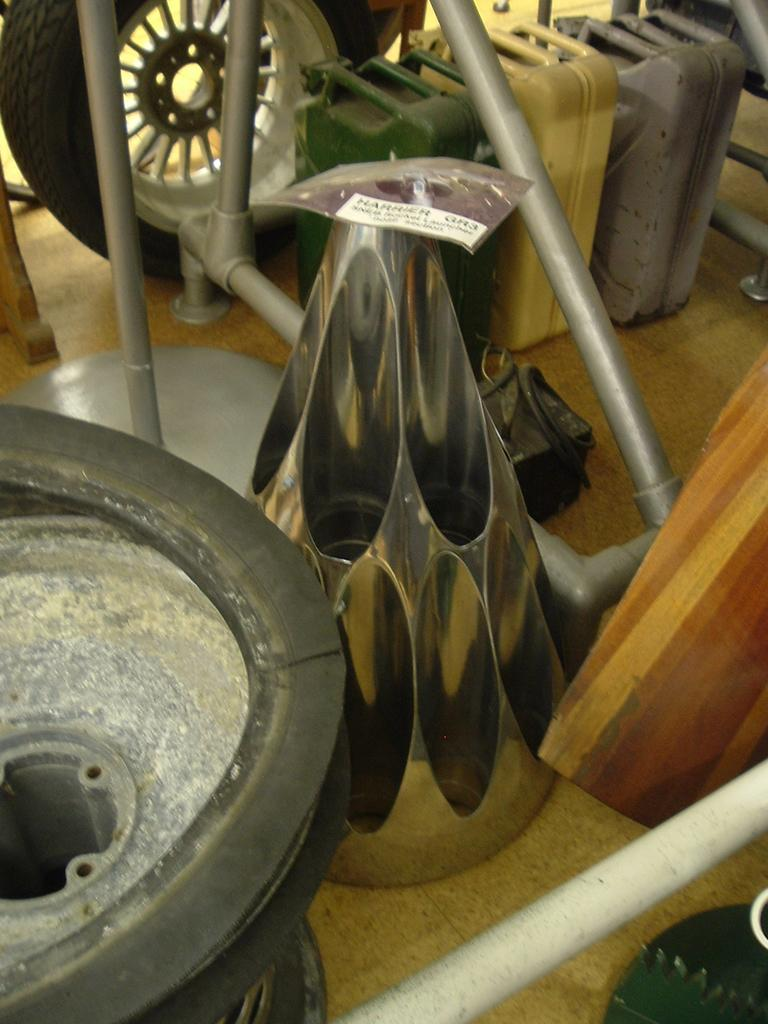What type of object can be seen with wheels in the image? The information provided does not specify what type of object has wheels in the image. What items are contained within the cans in the image? The contents of the cans are not visible or described in the provided facts. What is the material of the stands in the image? The material of the stands is not specified in the provided facts. What is the cone-shaped object made of in the image? The material of the cone-shaped object is not specified in the provided facts. What can be seen at the bottom of the image? The floor is visible at the bottom of the image. Where can the brain be seen in the image? There is no mention of a brain in the provided facts, so it cannot be seen in the image. What type of store is depicted in the image? The provided facts do not mention a store, so it cannot be determined from the image. 